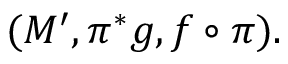<formula> <loc_0><loc_0><loc_500><loc_500>( M ^ { \prime } , \pi ^ { \ast } g , f \circ \pi ) .</formula> 